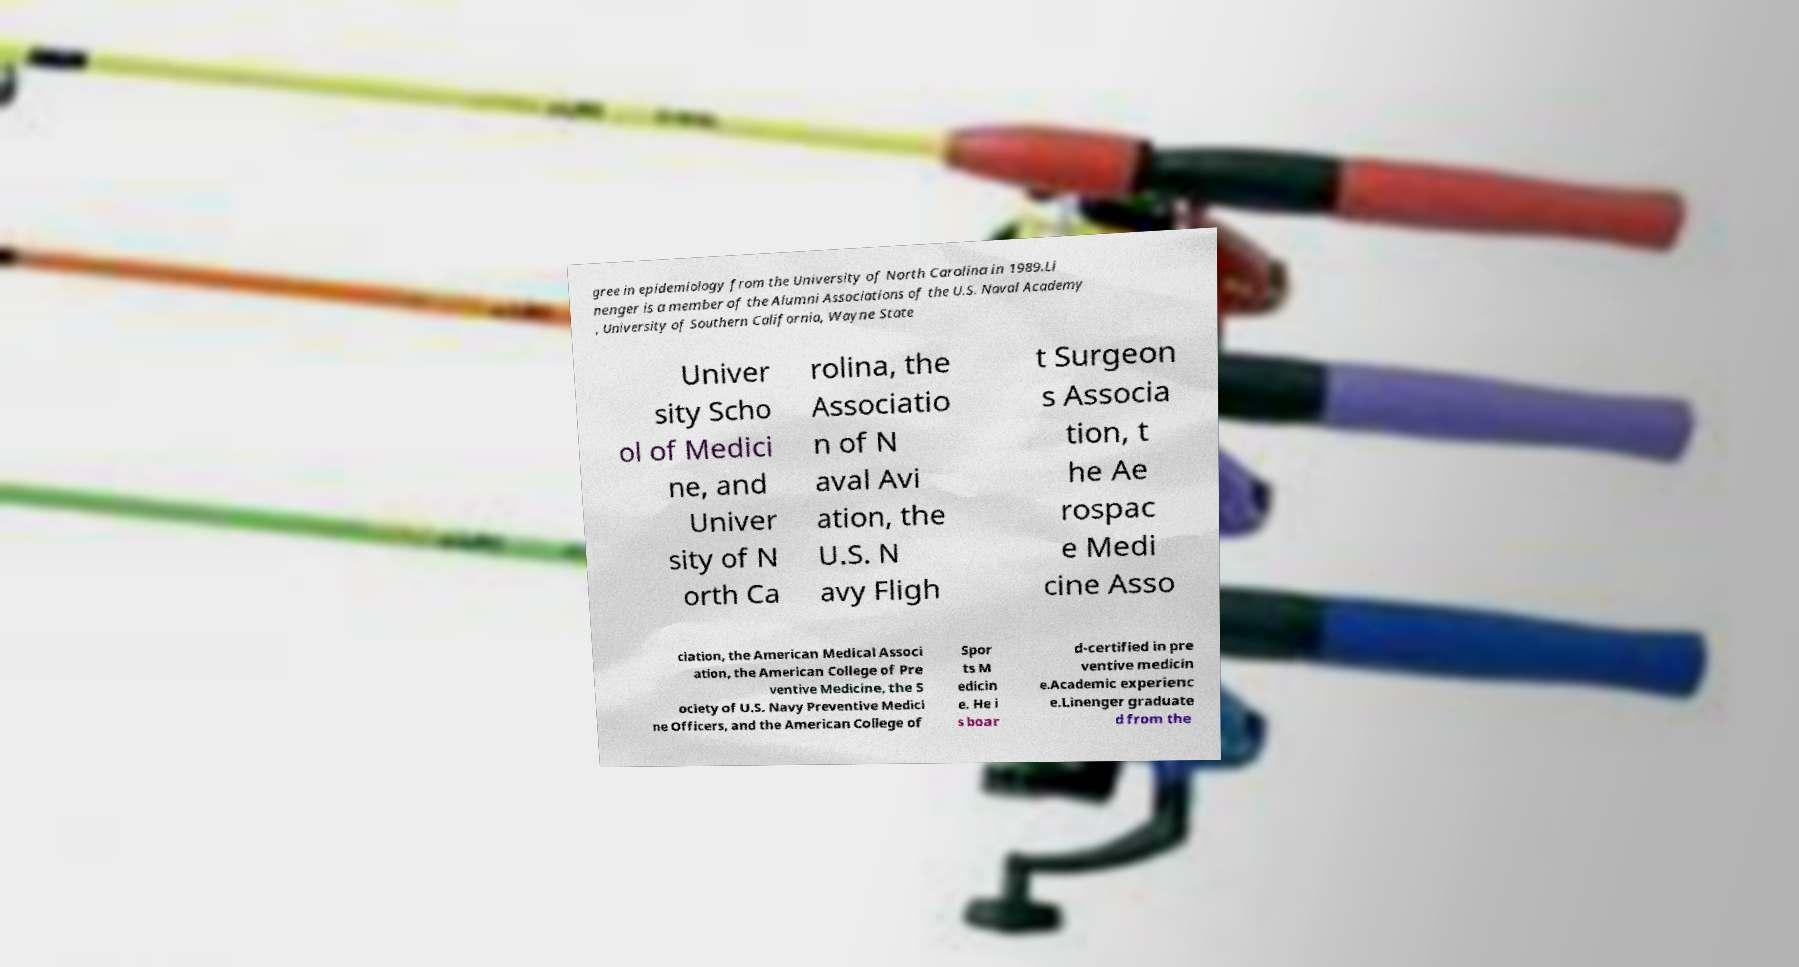There's text embedded in this image that I need extracted. Can you transcribe it verbatim? gree in epidemiology from the University of North Carolina in 1989.Li nenger is a member of the Alumni Associations of the U.S. Naval Academy , University of Southern California, Wayne State Univer sity Scho ol of Medici ne, and Univer sity of N orth Ca rolina, the Associatio n of N aval Avi ation, the U.S. N avy Fligh t Surgeon s Associa tion, t he Ae rospac e Medi cine Asso ciation, the American Medical Associ ation, the American College of Pre ventive Medicine, the S ociety of U.S. Navy Preventive Medici ne Officers, and the American College of Spor ts M edicin e. He i s boar d-certified in pre ventive medicin e.Academic experienc e.Linenger graduate d from the 